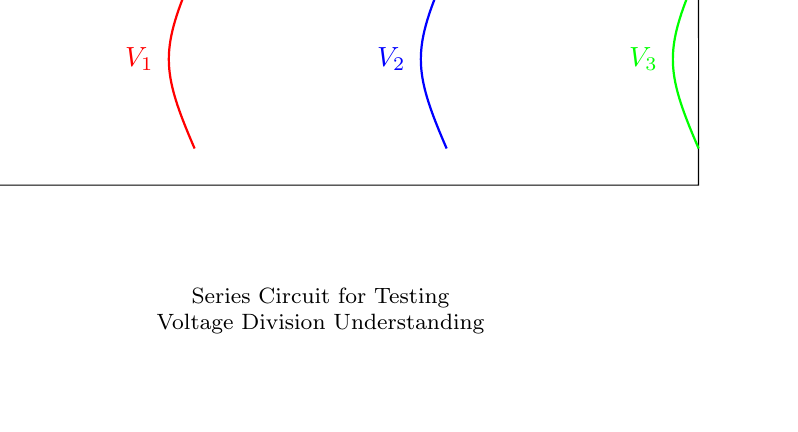What are the resistances in the circuit? The resistances in the circuit are labeled as R1, R2, and R3. They are the elements that oppose the flow of current.
Answer: R1, R2, R3 What is the total voltage supplied by the battery? The total voltage supplied by the battery is indicated as V_s. This is the voltage that drives the entire circuit.
Answer: V_s What is the voltage across R1? The voltage across R1 is denoted as V1, which represents the potential drop across this specific resistor in a series circuit.
Answer: V1 Explain how the voltage is divided among the resistors in series. In a series circuit, the total voltage is distributed among the resistors according to their resistances. The voltage drop across each resistor can be calculated using the formula: Vn = (Rn / R_total) * V_s, where Rn is the resistance of the specific resistor and R_total is the sum of all resistances. This means that the larger the resistance, the greater the voltage drop across it relative to others.
Answer: Voltage division rule What is the current flowing through each resistor? In a series circuit, the current flowing through each resistor is the same. This is due to the nature of series connections where there is only one path for the current to flow. The amount of current can be calculated using Ohm’s law: I = V_s / R_total.
Answer: I What happens to the total resistance if R2 is removed? If R2 is removed, the total resistance of the circuit will decrease since there will be one less resistor for the current to pass through. The new total resistance becomes the sum of the remaining resistors R1 and R3 only.
Answer: Decrease 